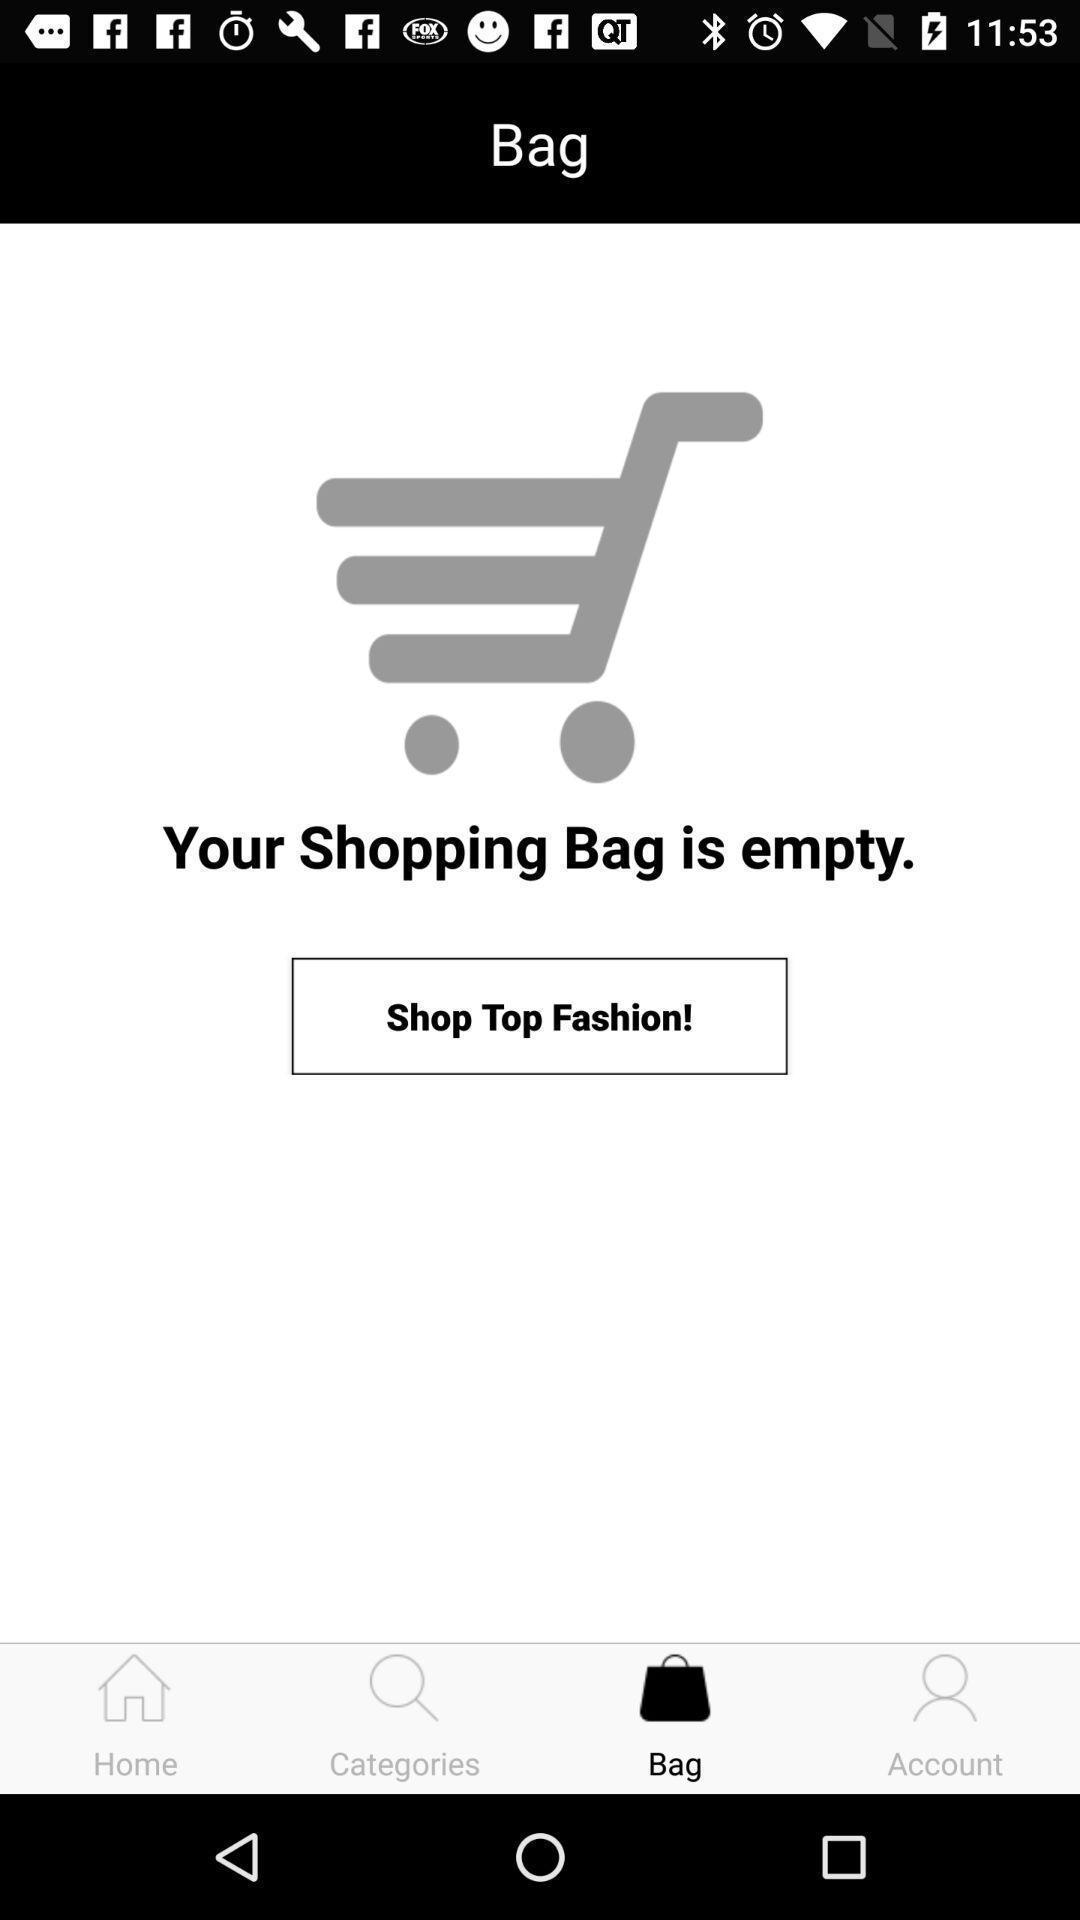Describe the content in this image. Screen displaying cart details in a shopping application. 